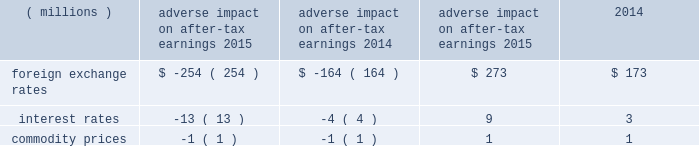Commodity prices risk : the company manages commodity price risks through negotiated supply contracts , price protection agreements and forward contracts .
3m used commodity price swaps as cash flow hedges of forecasted commodity transactions to manage price volatility , but discontinued this practice in the first quarter of 2015 .
The related mark-to-market gain or loss on qualifying hedges was included in other comprehensive income to the extent effective , and reclassified into cost of sales in the period during which the hedged transaction affected earnings .
Value at risk : the value at risk analysis is performed annually to assess the company 2019s sensitivity to changes in currency rates , interest rates , and commodity prices .
A monte carlo simulation technique was used to test the impact on after-tax earnings related to financial instruments ( primarily debt ) , derivatives and underlying exposures outstanding at december 31 , 2015 .
The model ( third-party bank dataset ) used a 95 percent confidence level over a 12-month time horizon .
The exposure to changes in currency rates model used 18 currencies , interest rates related to three currencies , and commodity prices related to five commodities .
This model does not purport to represent what actually will be experienced by the company .
This model does not include certain hedge transactions , because the company believes their inclusion would not materially impact the results .
The risk of loss or benefit associated with exchange rates was higher in 2015 due to a greater mix of floating rate debt and a rising interest rate environment in the u.s .
Interest rate volatility increased in 2015 , based on a higher mix of floating rate debt and the use of forward rates .
The table summarizes the possible adverse and positive impacts to after-tax earnings related to these exposures .
Adverse impact on after-tax positive impact on after-tax earnings earnings .
In addition to the possible adverse and positive impacts discussed in the preceding table related to foreign exchange rates , recent historical information is as follows .
3m estimates that year-on-year currency effects , including hedging impacts , had the following effects on pre-tax income : 2015 ( $ 390 million decrease ) and 2014 ( $ 100 million decrease ) .
This estimate includes the effect of translating profits from local currencies into u.s .
Dollars ; the impact of currency fluctuations on the transfer of goods between 3m operations in the united states and abroad ; and transaction gains and losses , including derivative instruments designed to reduce foreign currency exchange rate risks and the negative impact of swapping venezuelan bolivars into u.s .
Dollars .
3m estimates that year-on-year derivative and other transaction gains and losses had the following effects on pre-tax income : 2015 ( $ 180 million increase ) and 2014 ( $ 10 million increase ) .
An analysis of the global exposures related to purchased components and materials is performed at each year-end .
A one percent price change would result in a pre-tax cost or savings of approximately $ 70 million per year .
The global energy exposure is such that a ten percent price change would result in a pre-tax cost or savings of approximately $ 40 million per year .
Global energy exposure includes energy costs used in 3m production and other facilities , primarily electricity and natural gas. .
What was the net foreign exchange rate in 2015 in millions? 
Computations: (-254 + 273)
Answer: 19.0. 